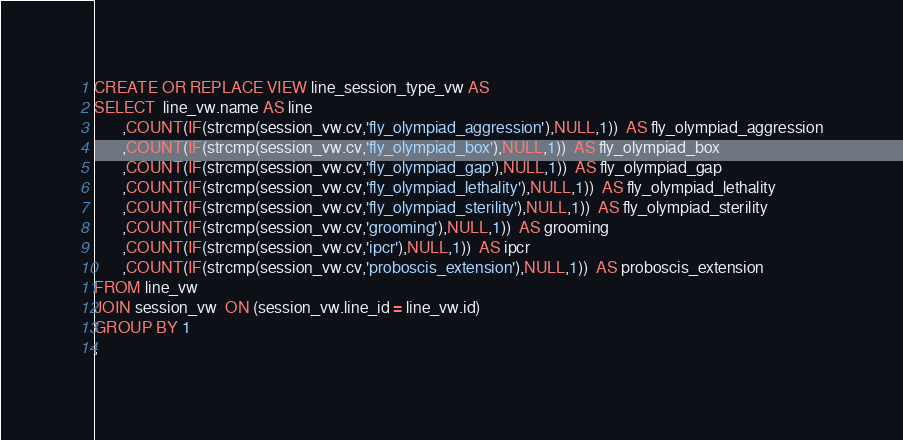<code> <loc_0><loc_0><loc_500><loc_500><_SQL_>CREATE OR REPLACE VIEW line_session_type_vw AS
SELECT  line_vw.name AS line
       ,COUNT(IF(strcmp(session_vw.cv,'fly_olympiad_aggression'),NULL,1))  AS fly_olympiad_aggression
       ,COUNT(IF(strcmp(session_vw.cv,'fly_olympiad_box'),NULL,1))  AS fly_olympiad_box
       ,COUNT(IF(strcmp(session_vw.cv,'fly_olympiad_gap'),NULL,1))  AS fly_olympiad_gap
       ,COUNT(IF(strcmp(session_vw.cv,'fly_olympiad_lethality'),NULL,1))  AS fly_olympiad_lethality
       ,COUNT(IF(strcmp(session_vw.cv,'fly_olympiad_sterility'),NULL,1))  AS fly_olympiad_sterility
       ,COUNT(IF(strcmp(session_vw.cv,'grooming'),NULL,1))  AS grooming
       ,COUNT(IF(strcmp(session_vw.cv,'ipcr'),NULL,1))  AS ipcr
       ,COUNT(IF(strcmp(session_vw.cv,'proboscis_extension'),NULL,1))  AS proboscis_extension
FROM line_vw
JOIN session_vw  ON (session_vw.line_id = line_vw.id)
GROUP BY 1
;
</code> 